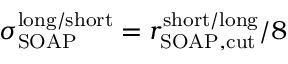<formula> <loc_0><loc_0><loc_500><loc_500>\sigma _ { S O A P } ^ { l o n g / s h o r t } = { r _ { S O A P , c u t } ^ { s h o r t / l o n g } } / 8</formula> 